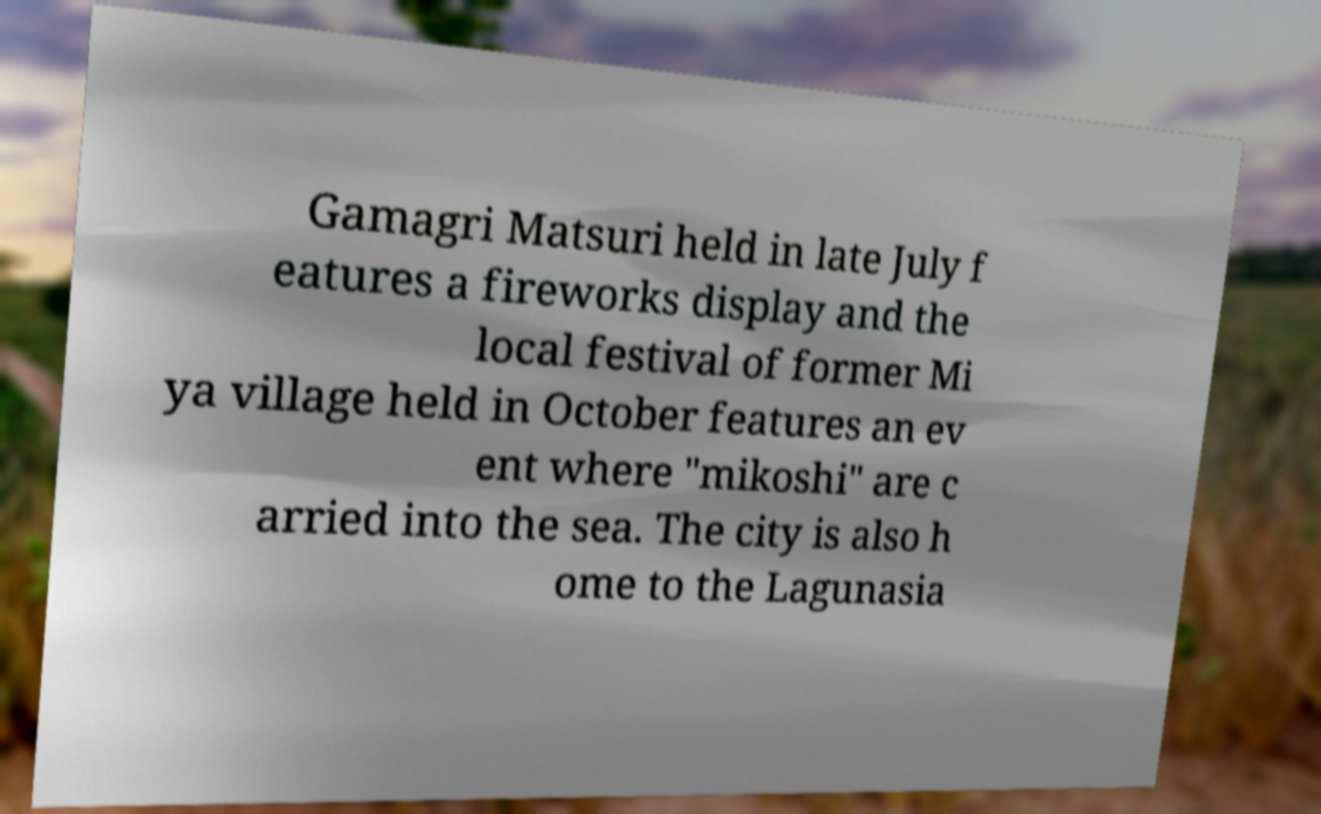Can you read and provide the text displayed in the image?This photo seems to have some interesting text. Can you extract and type it out for me? Gamagri Matsuri held in late July f eatures a fireworks display and the local festival of former Mi ya village held in October features an ev ent where "mikoshi" are c arried into the sea. The city is also h ome to the Lagunasia 